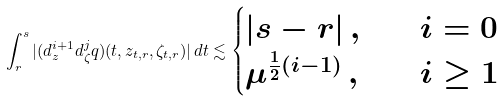Convert formula to latex. <formula><loc_0><loc_0><loc_500><loc_500>\int _ { r } ^ { s } | ( d ^ { i + 1 } _ { z } d ^ { j } _ { \zeta } q ) ( t , z _ { t , r } , \zeta _ { t , r } ) | \, d t \lesssim \begin{cases} | s - r | \, , & \quad i = 0 \\ \mu ^ { \frac { 1 } { 2 } ( i - 1 ) } \, , & \quad i \geq 1 \end{cases}</formula> 